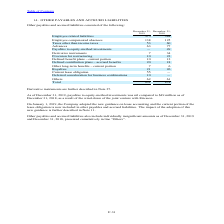According to Stmicroelectronics's financial document, How much was the payables to equity-method investments as of December 31, 2018? According to the financial document, $49 million. The relevant text states: "s to equity-method investments was nil compared to $49 million as of December 31, 2018, as a result of the wind-down of the joint venture with Ericsson...." Also, What was the new guideline adopted by the company on January 1, 2019? On January 1, 2019, the Company adopted the new guidance on lease accounting and the current portion of the lease obligation is now included in other payables and accrued liabilities.. The document states: "On January 1, 2019, the Company adopted the new guidance on lease accounting and the current portion of the lease obligation is now included in other ..." Also, How much was the  payables to equity-method investments as of December 31, 2019? According to the financial document, nil. The relevant text states: ", 2019, payables to equity-method investments was nil compared to $49 million as of December 31, 2018, as a result of the wind-down of the joint venture..." Also, can you calculate: What is the average Employee related liabilities? To answer this question, I need to perform calculations using the financial data. The calculation is: (375+384) / 2, which equals 379.5 (in millions). This is based on the information: "Employee related liabilities 375 384 Employee related liabilities 375 384..." The key data points involved are: 375, 384. Also, can you calculate: What is the average Employee compensated absences? To answer this question, I need to perform calculations using the financial data. The calculation is: (138+125) / 2 , which equals 131.5 (in millions). This is based on the information: "Employee compensated absences 138 125 Employee compensated absences 138 125..." The key data points involved are: 125, 138. Also, can you calculate: What is the average Taxes other than income taxes? To answer this question, I need to perform calculations using the financial data. The calculation is: (53+60) / 2, which equals 56.5 (in millions). This is based on the information: "Taxes other than income taxes 53 60 Taxes other than income taxes 53 60..." The key data points involved are: 53, 60. 